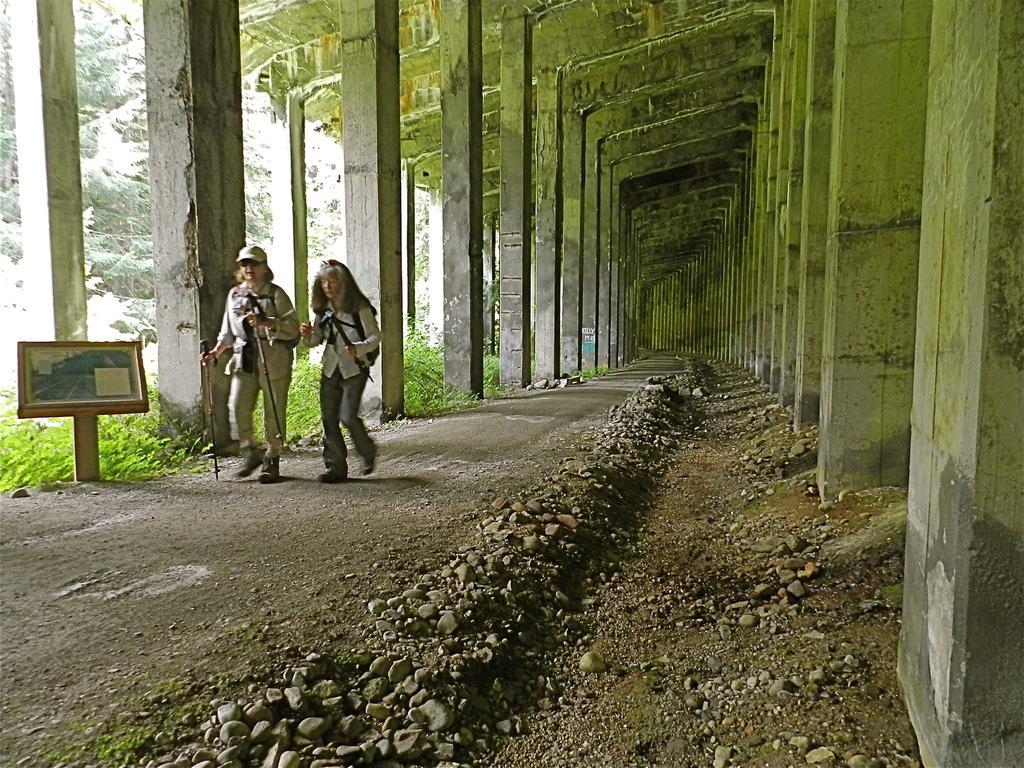Can you describe this image briefly? In this picture we can see an old woman who is wearing cap, goggles, shirt, trouser and shoe. She is holding sticks and bag. Besides her we can see another woman who is wearing shirt, bag, jeans and shoe. Both of them are walking on this land. On the left we can see a printing which is near to the pillar. On the right we can see building. Here we can see grass. On the bottom we can see stones. 